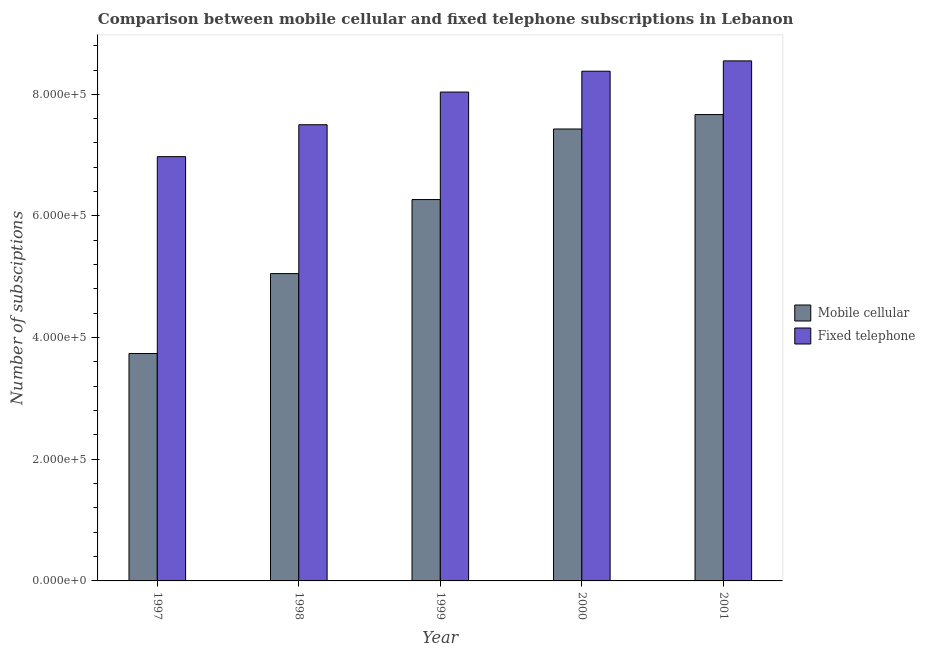How many different coloured bars are there?
Provide a short and direct response. 2. Are the number of bars per tick equal to the number of legend labels?
Your answer should be compact. Yes. How many bars are there on the 1st tick from the left?
Your answer should be very brief. 2. What is the label of the 1st group of bars from the left?
Ensure brevity in your answer.  1997. What is the number of mobile cellular subscriptions in 1997?
Your answer should be very brief. 3.74e+05. Across all years, what is the maximum number of mobile cellular subscriptions?
Provide a succinct answer. 7.67e+05. Across all years, what is the minimum number of fixed telephone subscriptions?
Your answer should be very brief. 6.98e+05. What is the total number of mobile cellular subscriptions in the graph?
Your answer should be compact. 3.02e+06. What is the difference between the number of fixed telephone subscriptions in 1998 and that in 1999?
Provide a succinct answer. -5.37e+04. What is the difference between the number of fixed telephone subscriptions in 2001 and the number of mobile cellular subscriptions in 1999?
Provide a short and direct response. 5.13e+04. What is the average number of fixed telephone subscriptions per year?
Your answer should be very brief. 7.89e+05. What is the ratio of the number of fixed telephone subscriptions in 1997 to that in 1999?
Give a very brief answer. 0.87. Is the number of mobile cellular subscriptions in 1999 less than that in 2001?
Your response must be concise. Yes. Is the difference between the number of mobile cellular subscriptions in 1997 and 1998 greater than the difference between the number of fixed telephone subscriptions in 1997 and 1998?
Ensure brevity in your answer.  No. What is the difference between the highest and the second highest number of fixed telephone subscriptions?
Your response must be concise. 1.70e+04. What is the difference between the highest and the lowest number of fixed telephone subscriptions?
Your answer should be compact. 1.57e+05. In how many years, is the number of fixed telephone subscriptions greater than the average number of fixed telephone subscriptions taken over all years?
Keep it short and to the point. 3. What does the 1st bar from the left in 1997 represents?
Offer a terse response. Mobile cellular. What does the 1st bar from the right in 2000 represents?
Ensure brevity in your answer.  Fixed telephone. How many bars are there?
Provide a short and direct response. 10. How many years are there in the graph?
Give a very brief answer. 5. Are the values on the major ticks of Y-axis written in scientific E-notation?
Provide a short and direct response. Yes. Where does the legend appear in the graph?
Your response must be concise. Center right. How many legend labels are there?
Offer a very short reply. 2. What is the title of the graph?
Your response must be concise. Comparison between mobile cellular and fixed telephone subscriptions in Lebanon. What is the label or title of the Y-axis?
Keep it short and to the point. Number of subsciptions. What is the Number of subsciptions of Mobile cellular in 1997?
Your response must be concise. 3.74e+05. What is the Number of subsciptions of Fixed telephone in 1997?
Provide a short and direct response. 6.98e+05. What is the Number of subsciptions in Mobile cellular in 1998?
Your answer should be very brief. 5.05e+05. What is the Number of subsciptions of Fixed telephone in 1998?
Give a very brief answer. 7.50e+05. What is the Number of subsciptions in Mobile cellular in 1999?
Provide a short and direct response. 6.27e+05. What is the Number of subsciptions of Fixed telephone in 1999?
Make the answer very short. 8.04e+05. What is the Number of subsciptions in Mobile cellular in 2000?
Keep it short and to the point. 7.43e+05. What is the Number of subsciptions of Fixed telephone in 2000?
Give a very brief answer. 8.38e+05. What is the Number of subsciptions in Mobile cellular in 2001?
Give a very brief answer. 7.67e+05. What is the Number of subsciptions of Fixed telephone in 2001?
Offer a terse response. 8.55e+05. Across all years, what is the maximum Number of subsciptions in Mobile cellular?
Offer a very short reply. 7.67e+05. Across all years, what is the maximum Number of subsciptions in Fixed telephone?
Offer a terse response. 8.55e+05. Across all years, what is the minimum Number of subsciptions in Mobile cellular?
Your response must be concise. 3.74e+05. Across all years, what is the minimum Number of subsciptions in Fixed telephone?
Give a very brief answer. 6.98e+05. What is the total Number of subsciptions of Mobile cellular in the graph?
Ensure brevity in your answer.  3.02e+06. What is the total Number of subsciptions in Fixed telephone in the graph?
Your answer should be very brief. 3.94e+06. What is the difference between the Number of subsciptions of Mobile cellular in 1997 and that in 1998?
Keep it short and to the point. -1.31e+05. What is the difference between the Number of subsciptions of Fixed telephone in 1997 and that in 1998?
Make the answer very short. -5.25e+04. What is the difference between the Number of subsciptions in Mobile cellular in 1997 and that in 1999?
Your answer should be very brief. -2.53e+05. What is the difference between the Number of subsciptions in Fixed telephone in 1997 and that in 1999?
Provide a succinct answer. -1.06e+05. What is the difference between the Number of subsciptions in Mobile cellular in 1997 and that in 2000?
Offer a very short reply. -3.69e+05. What is the difference between the Number of subsciptions of Fixed telephone in 1997 and that in 2000?
Give a very brief answer. -1.40e+05. What is the difference between the Number of subsciptions in Mobile cellular in 1997 and that in 2001?
Your answer should be very brief. -3.93e+05. What is the difference between the Number of subsciptions of Fixed telephone in 1997 and that in 2001?
Offer a very short reply. -1.57e+05. What is the difference between the Number of subsciptions of Mobile cellular in 1998 and that in 1999?
Your answer should be compact. -1.22e+05. What is the difference between the Number of subsciptions of Fixed telephone in 1998 and that in 1999?
Keep it short and to the point. -5.37e+04. What is the difference between the Number of subsciptions in Mobile cellular in 1998 and that in 2000?
Your answer should be compact. -2.38e+05. What is the difference between the Number of subsciptions of Fixed telephone in 1998 and that in 2000?
Provide a succinct answer. -8.80e+04. What is the difference between the Number of subsciptions in Mobile cellular in 1998 and that in 2001?
Offer a terse response. -2.61e+05. What is the difference between the Number of subsciptions in Fixed telephone in 1998 and that in 2001?
Your answer should be very brief. -1.05e+05. What is the difference between the Number of subsciptions in Mobile cellular in 1999 and that in 2000?
Ensure brevity in your answer.  -1.16e+05. What is the difference between the Number of subsciptions in Fixed telephone in 1999 and that in 2000?
Provide a short and direct response. -3.43e+04. What is the difference between the Number of subsciptions of Mobile cellular in 1999 and that in 2001?
Your response must be concise. -1.40e+05. What is the difference between the Number of subsciptions of Fixed telephone in 1999 and that in 2001?
Your response must be concise. -5.13e+04. What is the difference between the Number of subsciptions of Mobile cellular in 2000 and that in 2001?
Your answer should be compact. -2.38e+04. What is the difference between the Number of subsciptions in Fixed telephone in 2000 and that in 2001?
Offer a very short reply. -1.70e+04. What is the difference between the Number of subsciptions in Mobile cellular in 1997 and the Number of subsciptions in Fixed telephone in 1998?
Provide a short and direct response. -3.76e+05. What is the difference between the Number of subsciptions of Mobile cellular in 1997 and the Number of subsciptions of Fixed telephone in 1999?
Make the answer very short. -4.30e+05. What is the difference between the Number of subsciptions in Mobile cellular in 1997 and the Number of subsciptions in Fixed telephone in 2000?
Provide a succinct answer. -4.64e+05. What is the difference between the Number of subsciptions in Mobile cellular in 1997 and the Number of subsciptions in Fixed telephone in 2001?
Your answer should be compact. -4.81e+05. What is the difference between the Number of subsciptions in Mobile cellular in 1998 and the Number of subsciptions in Fixed telephone in 1999?
Make the answer very short. -2.98e+05. What is the difference between the Number of subsciptions of Mobile cellular in 1998 and the Number of subsciptions of Fixed telephone in 2000?
Make the answer very short. -3.33e+05. What is the difference between the Number of subsciptions of Mobile cellular in 1998 and the Number of subsciptions of Fixed telephone in 2001?
Your answer should be compact. -3.50e+05. What is the difference between the Number of subsciptions of Mobile cellular in 1999 and the Number of subsciptions of Fixed telephone in 2000?
Your response must be concise. -2.11e+05. What is the difference between the Number of subsciptions in Mobile cellular in 1999 and the Number of subsciptions in Fixed telephone in 2001?
Provide a short and direct response. -2.28e+05. What is the difference between the Number of subsciptions in Mobile cellular in 2000 and the Number of subsciptions in Fixed telephone in 2001?
Your answer should be very brief. -1.12e+05. What is the average Number of subsciptions in Mobile cellular per year?
Your answer should be compact. 6.03e+05. What is the average Number of subsciptions of Fixed telephone per year?
Offer a very short reply. 7.89e+05. In the year 1997, what is the difference between the Number of subsciptions in Mobile cellular and Number of subsciptions in Fixed telephone?
Ensure brevity in your answer.  -3.24e+05. In the year 1998, what is the difference between the Number of subsciptions in Mobile cellular and Number of subsciptions in Fixed telephone?
Make the answer very short. -2.45e+05. In the year 1999, what is the difference between the Number of subsciptions of Mobile cellular and Number of subsciptions of Fixed telephone?
Your answer should be compact. -1.77e+05. In the year 2000, what is the difference between the Number of subsciptions of Mobile cellular and Number of subsciptions of Fixed telephone?
Give a very brief answer. -9.50e+04. In the year 2001, what is the difference between the Number of subsciptions in Mobile cellular and Number of subsciptions in Fixed telephone?
Your answer should be compact. -8.82e+04. What is the ratio of the Number of subsciptions of Mobile cellular in 1997 to that in 1998?
Offer a very short reply. 0.74. What is the ratio of the Number of subsciptions of Fixed telephone in 1997 to that in 1998?
Your answer should be compact. 0.93. What is the ratio of the Number of subsciptions in Mobile cellular in 1997 to that in 1999?
Ensure brevity in your answer.  0.6. What is the ratio of the Number of subsciptions in Fixed telephone in 1997 to that in 1999?
Your answer should be compact. 0.87. What is the ratio of the Number of subsciptions in Mobile cellular in 1997 to that in 2000?
Your response must be concise. 0.5. What is the ratio of the Number of subsciptions of Fixed telephone in 1997 to that in 2000?
Provide a short and direct response. 0.83. What is the ratio of the Number of subsciptions in Mobile cellular in 1997 to that in 2001?
Provide a short and direct response. 0.49. What is the ratio of the Number of subsciptions of Fixed telephone in 1997 to that in 2001?
Provide a short and direct response. 0.82. What is the ratio of the Number of subsciptions of Mobile cellular in 1998 to that in 1999?
Provide a short and direct response. 0.81. What is the ratio of the Number of subsciptions in Fixed telephone in 1998 to that in 1999?
Your answer should be compact. 0.93. What is the ratio of the Number of subsciptions of Mobile cellular in 1998 to that in 2000?
Give a very brief answer. 0.68. What is the ratio of the Number of subsciptions of Fixed telephone in 1998 to that in 2000?
Offer a very short reply. 0.9. What is the ratio of the Number of subsciptions in Mobile cellular in 1998 to that in 2001?
Offer a terse response. 0.66. What is the ratio of the Number of subsciptions in Fixed telephone in 1998 to that in 2001?
Provide a short and direct response. 0.88. What is the ratio of the Number of subsciptions of Mobile cellular in 1999 to that in 2000?
Offer a very short reply. 0.84. What is the ratio of the Number of subsciptions in Fixed telephone in 1999 to that in 2000?
Offer a terse response. 0.96. What is the ratio of the Number of subsciptions in Mobile cellular in 1999 to that in 2001?
Your response must be concise. 0.82. What is the ratio of the Number of subsciptions of Fixed telephone in 1999 to that in 2001?
Ensure brevity in your answer.  0.94. What is the ratio of the Number of subsciptions in Fixed telephone in 2000 to that in 2001?
Provide a succinct answer. 0.98. What is the difference between the highest and the second highest Number of subsciptions in Mobile cellular?
Provide a short and direct response. 2.38e+04. What is the difference between the highest and the second highest Number of subsciptions in Fixed telephone?
Your response must be concise. 1.70e+04. What is the difference between the highest and the lowest Number of subsciptions in Mobile cellular?
Your answer should be very brief. 3.93e+05. What is the difference between the highest and the lowest Number of subsciptions of Fixed telephone?
Ensure brevity in your answer.  1.57e+05. 